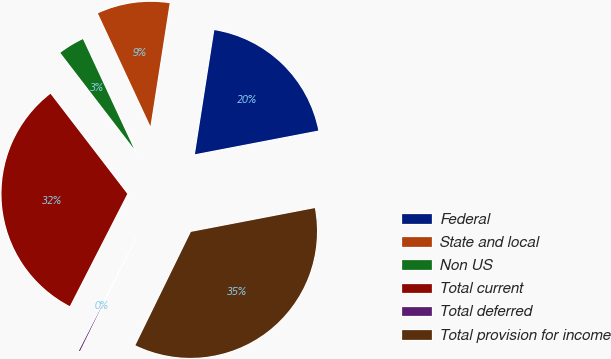Convert chart. <chart><loc_0><loc_0><loc_500><loc_500><pie_chart><fcel>Federal<fcel>State and local<fcel>Non US<fcel>Total current<fcel>Total deferred<fcel>Total provision for income<nl><fcel>19.51%<fcel>9.4%<fcel>3.49%<fcel>32.05%<fcel>0.29%<fcel>35.26%<nl></chart> 